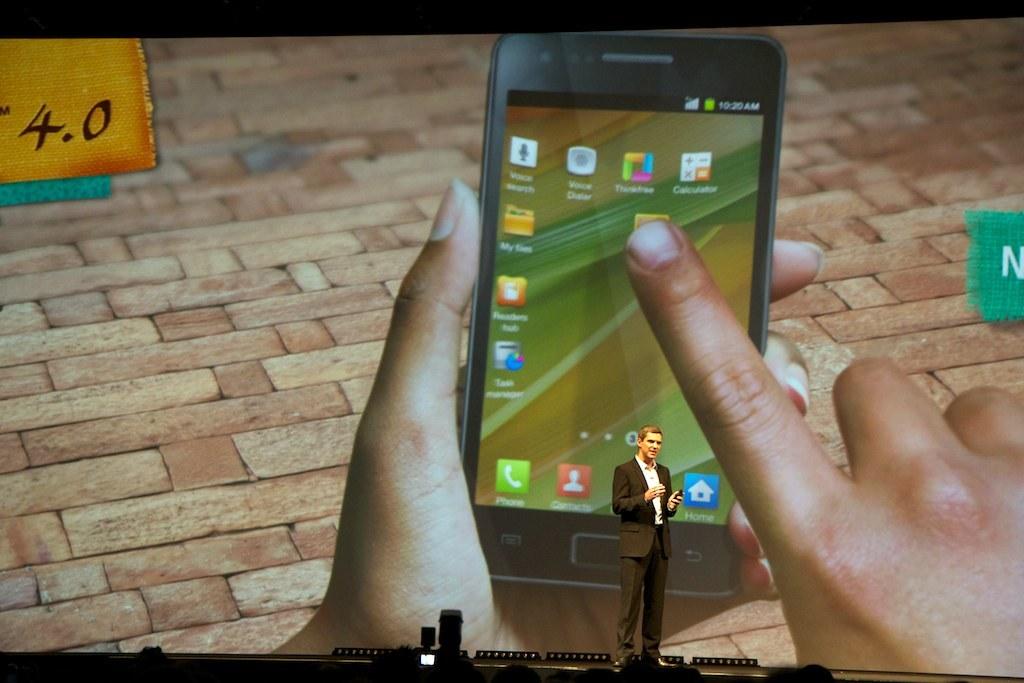What is the number displayed on the top left corner?
Offer a terse response. 4.0. 